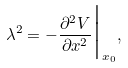Convert formula to latex. <formula><loc_0><loc_0><loc_500><loc_500>\lambda ^ { 2 } = - \frac { \partial ^ { 2 } V } { \partial x ^ { 2 } } \Big | _ { x _ { 0 } } ,</formula> 